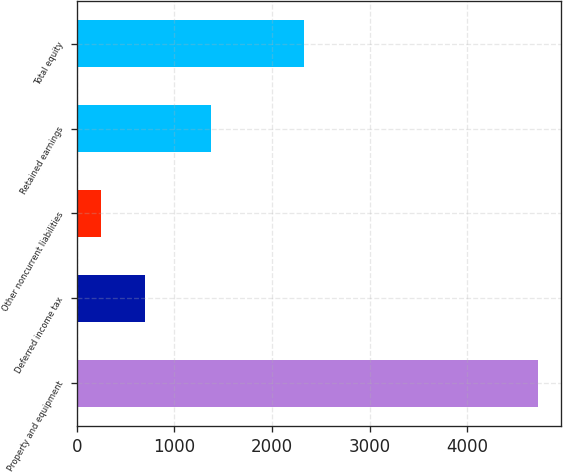<chart> <loc_0><loc_0><loc_500><loc_500><bar_chart><fcel>Property and equipment<fcel>Deferred income tax<fcel>Other noncurrent liabilities<fcel>Retained earnings<fcel>Total equity<nl><fcel>4722.4<fcel>694.72<fcel>247.2<fcel>1378.8<fcel>2325.8<nl></chart> 